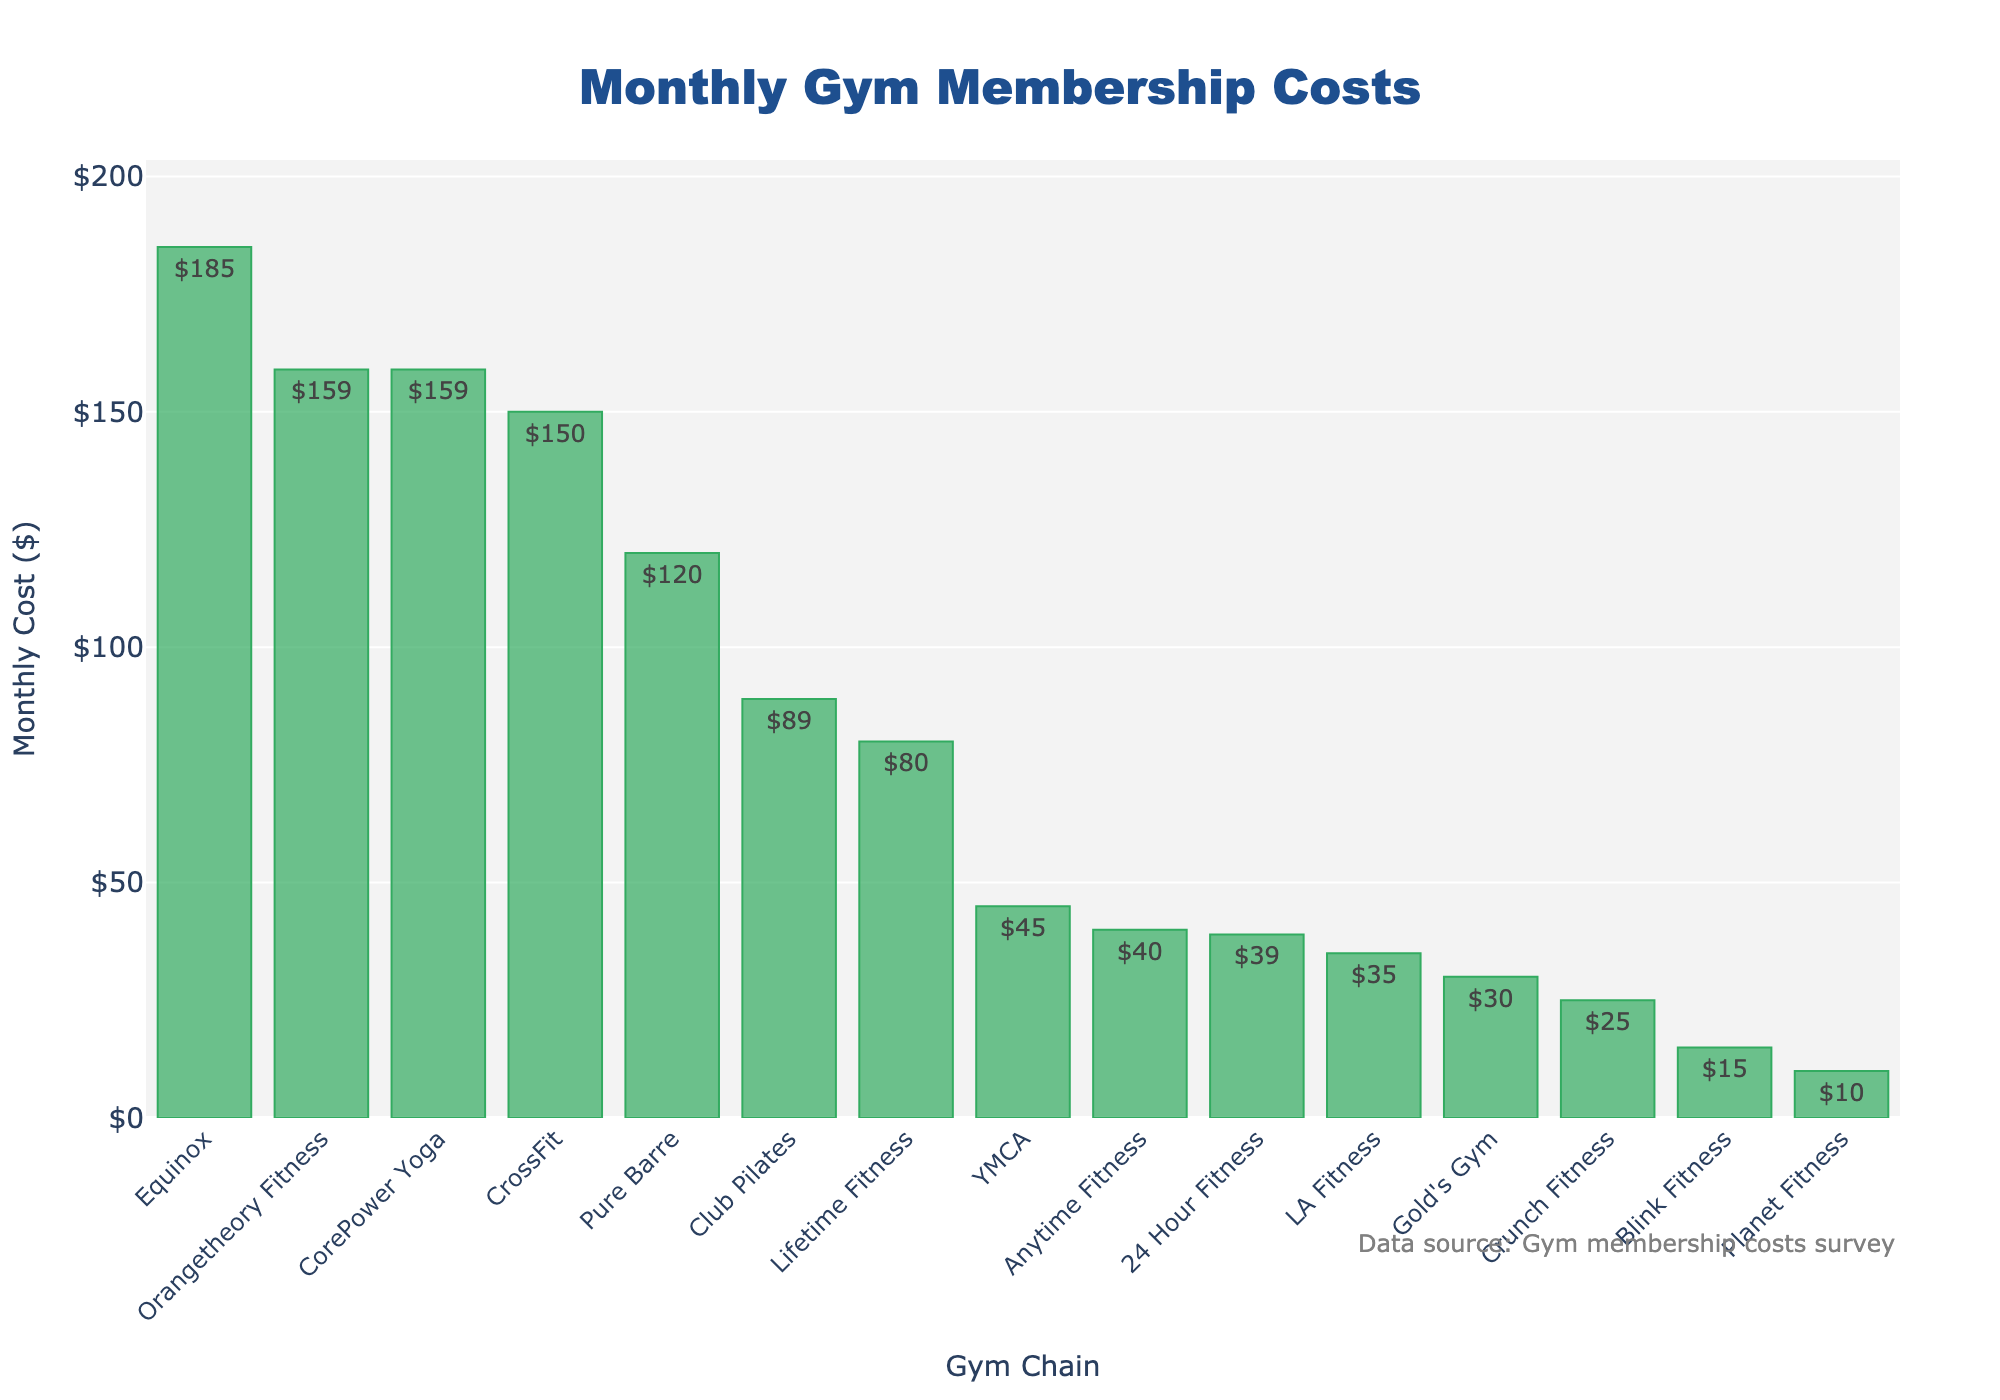What is the monthly cost of the most expensive gym chain? The gym chain with the highest bar represents the most expensive monthly cost. Equinox has the highest bar.
Answer: $185 What is the total monthly cost if you combine the memberships of Planet Fitness and Equinox? Planet Fitness costs $10 and Equinox costs $185. Adding them together gives $10 + $185.
Answer: $195 Which gym chain has the lowest monthly cost? The gym chain with the shortest bar represents the lowest monthly cost. This is Planet Fitness.
Answer: Planet Fitness Which is more expensive, CorePower Yoga or Pure Barre? Compare the heights of the bars for CorePower Yoga and Pure Barre. CorePower Yoga and Pure Barre both have bars at the same height of $159 for CorePower Yoga and $120 for Pure Barre.
Answer: CorePower Yoga How much more expensive is Lifetime Fitness compared to Blink Fitness? Lifetime Fitness costs $80 per month and Blink Fitness costs $15 per month. The difference is $80 - $15.
Answer: $65 What is the average monthly cost of 24 Hour Fitness, LA Fitness, and Gold's Gym? Add the monthly costs of 24 Hour Fitness ($39), LA Fitness ($35), and Gold's Gym ($30) and divide by 3. ($39 + $35 + $30) / 3 = $34.67
Answer: $34.67 Between CrossFit and Orangetheory Fitness, which gym chain has a higher monthly cost? Compare the heights of the bars for CrossFit and Orangetheory Fitness. CrossFit is at $150 and Orangetheory Fitness is at $159.
Answer: Orangetheory Fitness How much do you save per month by choosing Crunch Fitness over Club Pilates? Crunch Fitness costs $25 and Club Pilates costs $89. The savings is $89 - $25.
Answer: $64 Which gym chain is directly in the middle of the list when sorted by monthly cost? When sorted by monthly cost, the middle gym chain is Gold's Gym as there are 14 gym chains total, and Gold's Gym is the 7th from the top and 8th from the bottom.
Answer: Gold's Gym What is the median monthly cost of all the gym chains? First, arrange the monthly costs in numerical order: 10, 15, 25, 30, 35, 39, 40, 45, 80, 89, 120, 150, 159, 159, 185. The median is the middle value in this ordered list.
Answer: $45 